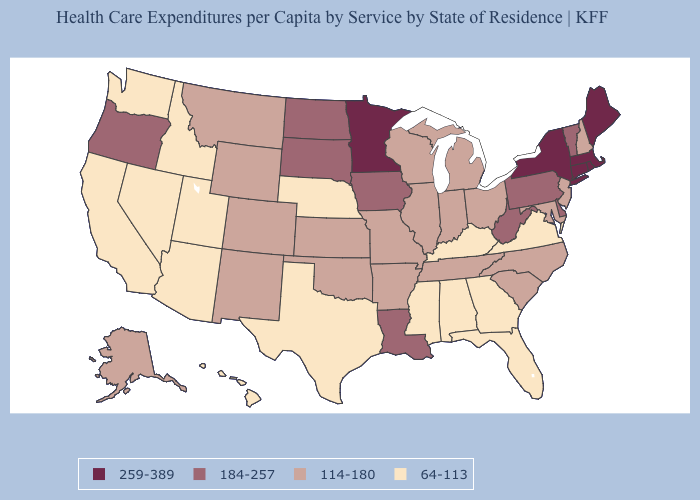Does the map have missing data?
Answer briefly. No. Does North Carolina have a higher value than Kansas?
Short answer required. No. Name the states that have a value in the range 64-113?
Answer briefly. Alabama, Arizona, California, Florida, Georgia, Hawaii, Idaho, Kentucky, Mississippi, Nebraska, Nevada, Texas, Utah, Virginia, Washington. What is the value of Kansas?
Be succinct. 114-180. Does the first symbol in the legend represent the smallest category?
Quick response, please. No. What is the value of Oregon?
Be succinct. 184-257. Which states have the highest value in the USA?
Be succinct. Connecticut, Maine, Massachusetts, Minnesota, New York, Rhode Island. Does Idaho have a lower value than West Virginia?
Keep it brief. Yes. Is the legend a continuous bar?
Write a very short answer. No. Name the states that have a value in the range 259-389?
Give a very brief answer. Connecticut, Maine, Massachusetts, Minnesota, New York, Rhode Island. Name the states that have a value in the range 184-257?
Quick response, please. Delaware, Iowa, Louisiana, North Dakota, Oregon, Pennsylvania, South Dakota, Vermont, West Virginia. Does Massachusetts have the highest value in the USA?
Keep it brief. Yes. What is the value of Delaware?
Be succinct. 184-257. Among the states that border Texas , which have the lowest value?
Keep it brief. Arkansas, New Mexico, Oklahoma. Name the states that have a value in the range 184-257?
Short answer required. Delaware, Iowa, Louisiana, North Dakota, Oregon, Pennsylvania, South Dakota, Vermont, West Virginia. 